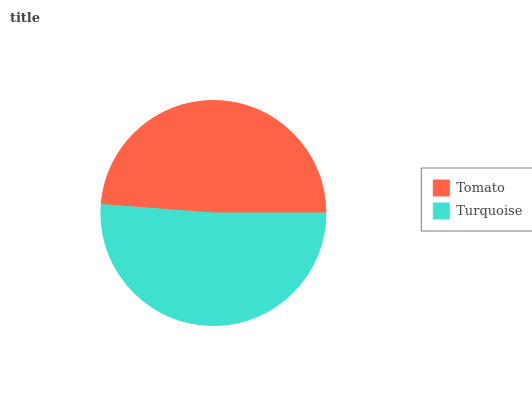Is Tomato the minimum?
Answer yes or no. Yes. Is Turquoise the maximum?
Answer yes or no. Yes. Is Turquoise the minimum?
Answer yes or no. No. Is Turquoise greater than Tomato?
Answer yes or no. Yes. Is Tomato less than Turquoise?
Answer yes or no. Yes. Is Tomato greater than Turquoise?
Answer yes or no. No. Is Turquoise less than Tomato?
Answer yes or no. No. Is Turquoise the high median?
Answer yes or no. Yes. Is Tomato the low median?
Answer yes or no. Yes. Is Tomato the high median?
Answer yes or no. No. Is Turquoise the low median?
Answer yes or no. No. 